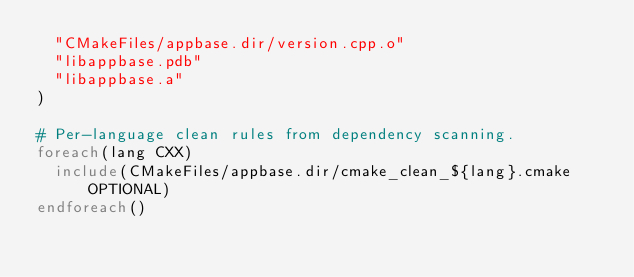<code> <loc_0><loc_0><loc_500><loc_500><_CMake_>  "CMakeFiles/appbase.dir/version.cpp.o"
  "libappbase.pdb"
  "libappbase.a"
)

# Per-language clean rules from dependency scanning.
foreach(lang CXX)
  include(CMakeFiles/appbase.dir/cmake_clean_${lang}.cmake OPTIONAL)
endforeach()
</code> 